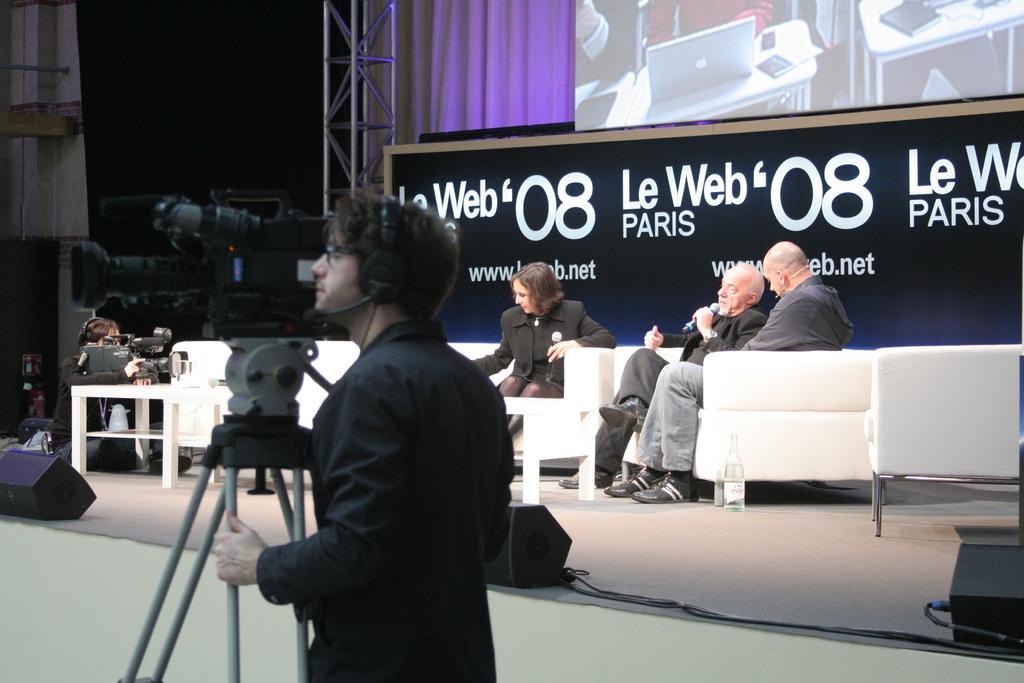How would you summarize this image in a sentence or two? In this image i can see a person holding a camera and behind him i can see a people sitting on the chairs,board with some text and stand. 